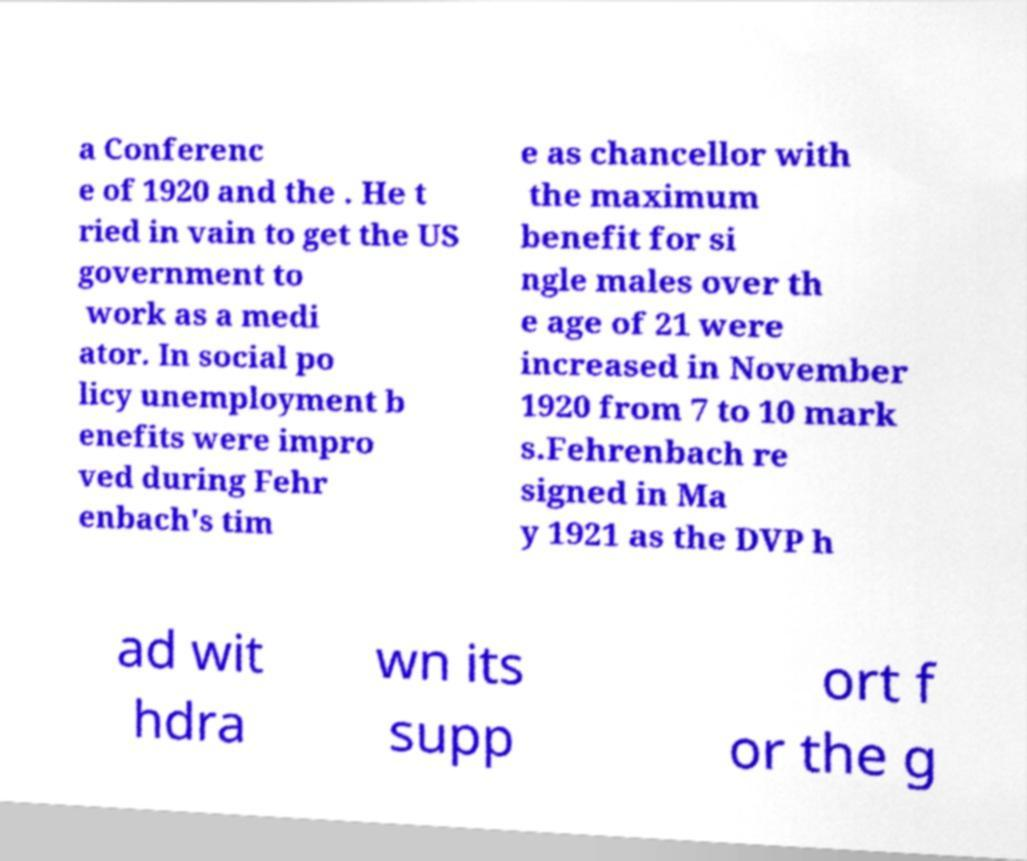For documentation purposes, I need the text within this image transcribed. Could you provide that? a Conferenc e of 1920 and the . He t ried in vain to get the US government to work as a medi ator. In social po licy unemployment b enefits were impro ved during Fehr enbach's tim e as chancellor with the maximum benefit for si ngle males over th e age of 21 were increased in November 1920 from 7 to 10 mark s.Fehrenbach re signed in Ma y 1921 as the DVP h ad wit hdra wn its supp ort f or the g 